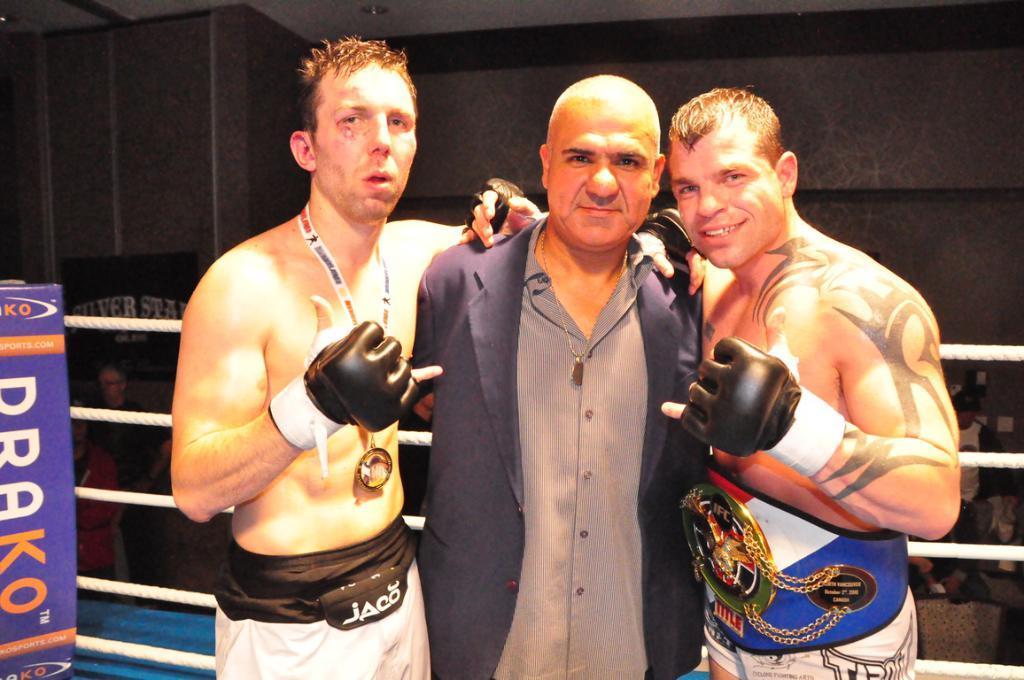Describe this image in one or two sentences. In this picture, we see three men are standing. Two of them are smiling and they are posing for the photo. On the left side, we see a board in blue color with some text written on it. Behind them, we see ropes and it might be a boxing ring. Behind them,we see many people are sitting on the chairs. In the background, we see a wall. 